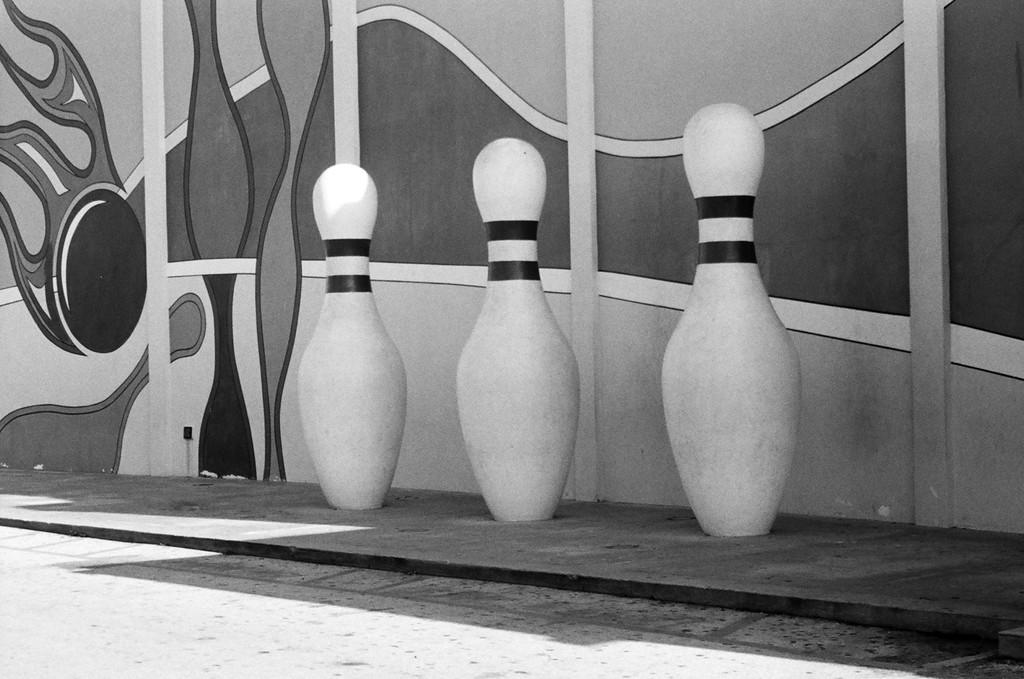How many bowling balls are visible in the image? There are three bowling balls in the image. Where are the bowling balls located? The bowling balls are on the floor. What can be seen in the background of the image? There is a wall in the background of the image. What is on the wall in the image? There is a painting on the wall. What type of faucet is visible in the image? There is no faucet present in the image. How old is the boy in the image? There is no boy present in the image. 